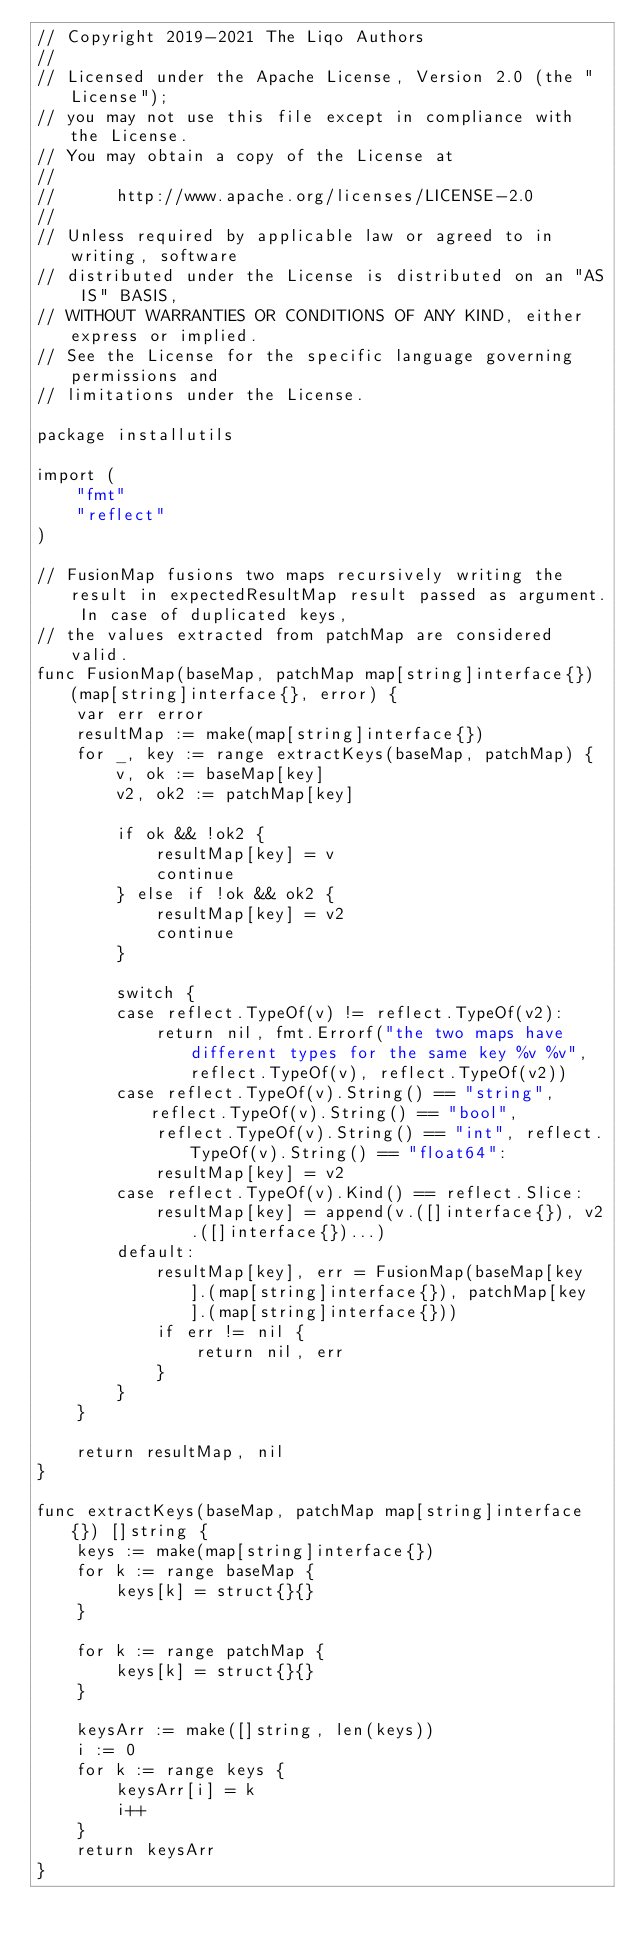<code> <loc_0><loc_0><loc_500><loc_500><_Go_>// Copyright 2019-2021 The Liqo Authors
//
// Licensed under the Apache License, Version 2.0 (the "License");
// you may not use this file except in compliance with the License.
// You may obtain a copy of the License at
//
//      http://www.apache.org/licenses/LICENSE-2.0
//
// Unless required by applicable law or agreed to in writing, software
// distributed under the License is distributed on an "AS IS" BASIS,
// WITHOUT WARRANTIES OR CONDITIONS OF ANY KIND, either express or implied.
// See the License for the specific language governing permissions and
// limitations under the License.

package installutils

import (
	"fmt"
	"reflect"
)

// FusionMap fusions two maps recursively writing the result in expectedResultMap result passed as argument. In case of duplicated keys,
// the values extracted from patchMap are considered valid.
func FusionMap(baseMap, patchMap map[string]interface{}) (map[string]interface{}, error) {
	var err error
	resultMap := make(map[string]interface{})
	for _, key := range extractKeys(baseMap, patchMap) {
		v, ok := baseMap[key]
		v2, ok2 := patchMap[key]

		if ok && !ok2 {
			resultMap[key] = v
			continue
		} else if !ok && ok2 {
			resultMap[key] = v2
			continue
		}

		switch {
		case reflect.TypeOf(v) != reflect.TypeOf(v2):
			return nil, fmt.Errorf("the two maps have different types for the same key %v %v", reflect.TypeOf(v), reflect.TypeOf(v2))
		case reflect.TypeOf(v).String() == "string", reflect.TypeOf(v).String() == "bool",
			reflect.TypeOf(v).String() == "int", reflect.TypeOf(v).String() == "float64":
			resultMap[key] = v2
		case reflect.TypeOf(v).Kind() == reflect.Slice:
			resultMap[key] = append(v.([]interface{}), v2.([]interface{})...)
		default:
			resultMap[key], err = FusionMap(baseMap[key].(map[string]interface{}), patchMap[key].(map[string]interface{}))
			if err != nil {
				return nil, err
			}
		}
	}

	return resultMap, nil
}

func extractKeys(baseMap, patchMap map[string]interface{}) []string {
	keys := make(map[string]interface{})
	for k := range baseMap {
		keys[k] = struct{}{}
	}

	for k := range patchMap {
		keys[k] = struct{}{}
	}

	keysArr := make([]string, len(keys))
	i := 0
	for k := range keys {
		keysArr[i] = k
		i++
	}
	return keysArr
}
</code> 